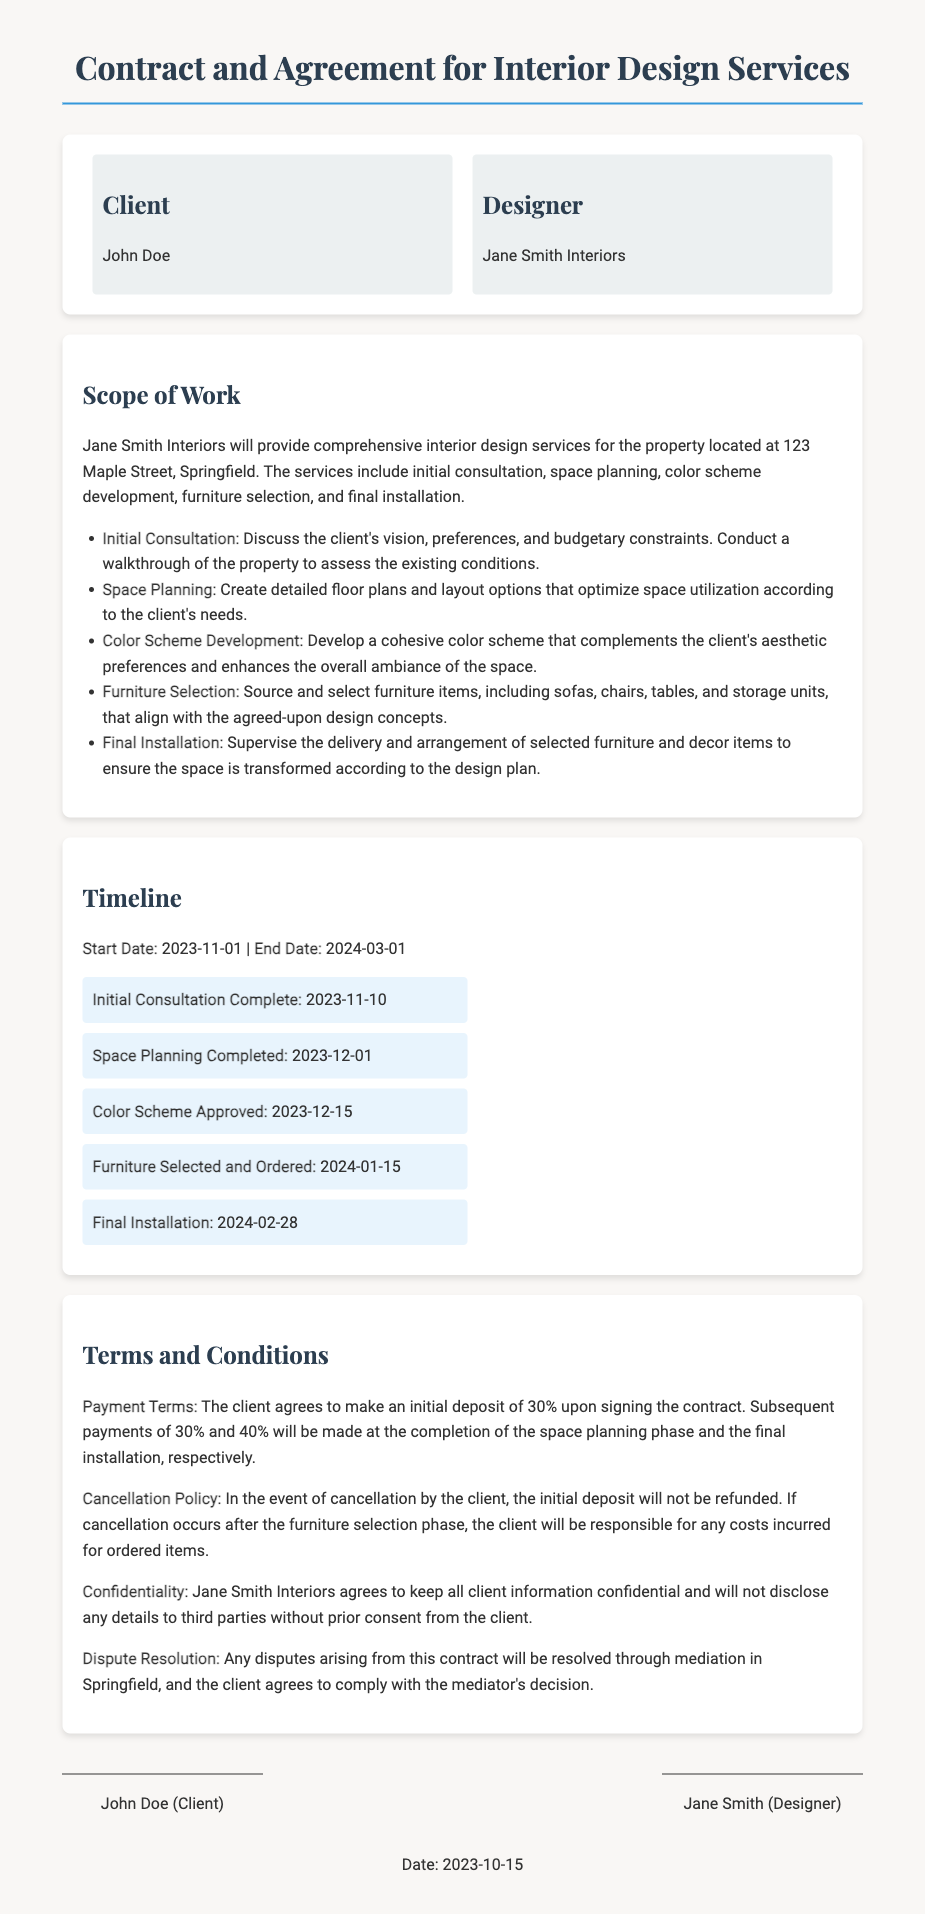what is the client's name? The client's name is mentioned in the parties section of the document.
Answer: John Doe who is the designer? The designer's name is stated under the designer section in the document.
Answer: Jane Smith Interiors what is the start date of the project? The start date is explicitly stated in the timeline section of the document.
Answer: 2023-11-01 when is the final installation scheduled to be completed? The completion date for the final installation is listed in the timeline section.
Answer: 2024-02-28 what percentage of the initial deposit is required upon signing? The payment terms section specifies the percentage needed for the initial deposit.
Answer: 30% how many phases are there in the design process according to the scope of work? The scope of work outlines various phases of the design process.
Answer: 5 what is required before the final installation? This question combines the understanding of different sections regarding the process leading to final installation.
Answer: Furniture Selected and Ordered what is the cancellation policy regarding the initial deposit? The cancellation policy outlines what happens to the deposit if the client cancels.
Answer: Not refunded which city will disputes be resolved in? The document specifies the location for mediation in the dispute resolution section.
Answer: Springfield 